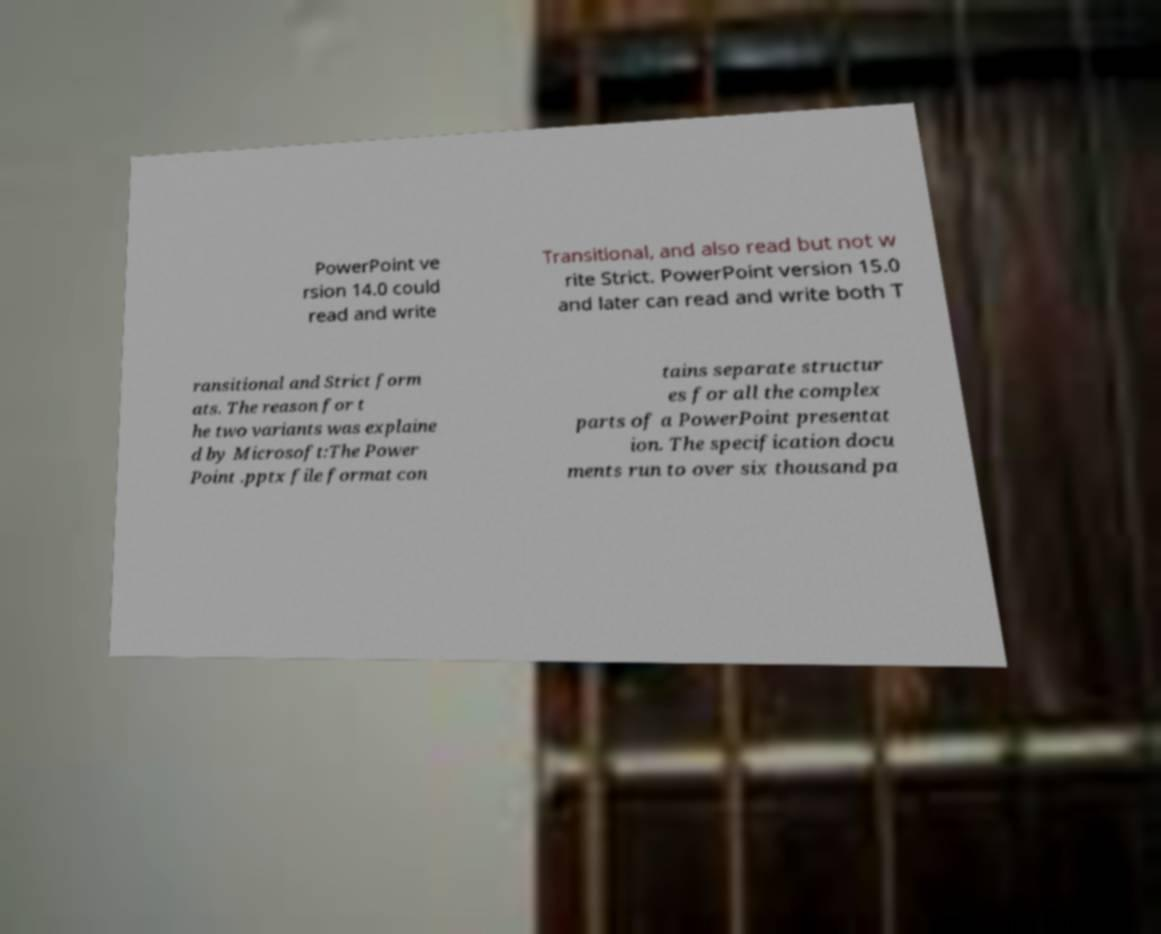What messages or text are displayed in this image? I need them in a readable, typed format. PowerPoint ve rsion 14.0 could read and write Transitional, and also read but not w rite Strict. PowerPoint version 15.0 and later can read and write both T ransitional and Strict form ats. The reason for t he two variants was explaine d by Microsoft:The Power Point .pptx file format con tains separate structur es for all the complex parts of a PowerPoint presentat ion. The specification docu ments run to over six thousand pa 